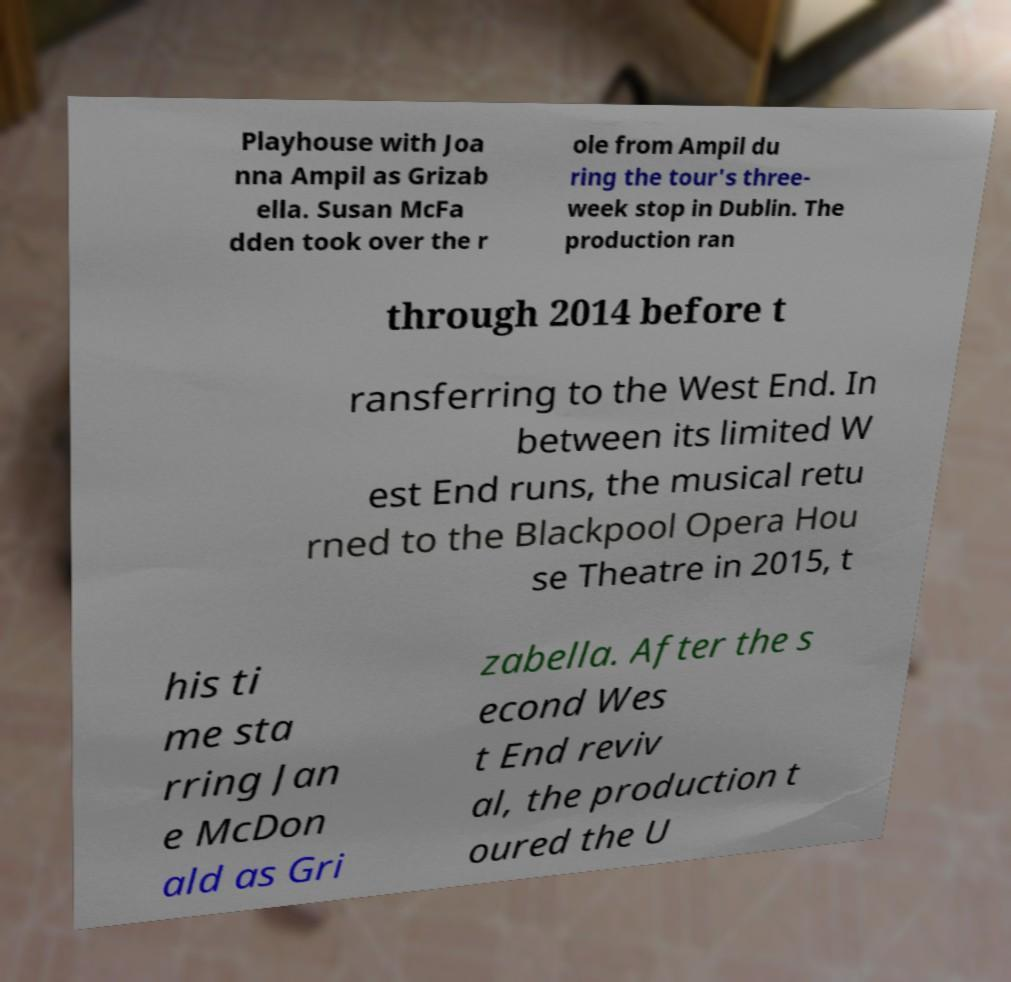Can you accurately transcribe the text from the provided image for me? Playhouse with Joa nna Ampil as Grizab ella. Susan McFa dden took over the r ole from Ampil du ring the tour's three- week stop in Dublin. The production ran through 2014 before t ransferring to the West End. In between its limited W est End runs, the musical retu rned to the Blackpool Opera Hou se Theatre in 2015, t his ti me sta rring Jan e McDon ald as Gri zabella. After the s econd Wes t End reviv al, the production t oured the U 